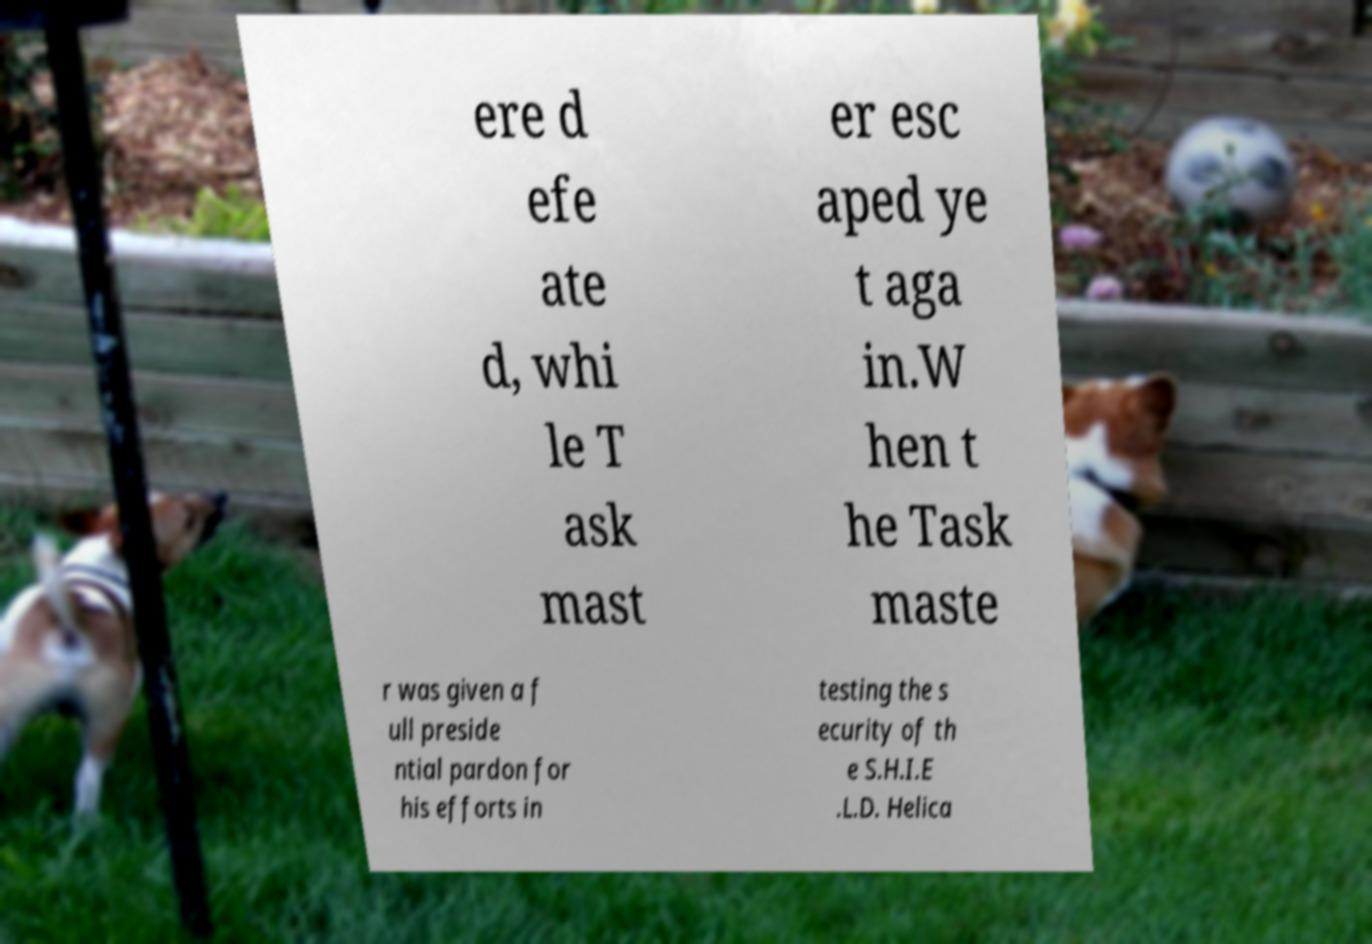Can you accurately transcribe the text from the provided image for me? ere d efe ate d, whi le T ask mast er esc aped ye t aga in.W hen t he Task maste r was given a f ull preside ntial pardon for his efforts in testing the s ecurity of th e S.H.I.E .L.D. Helica 